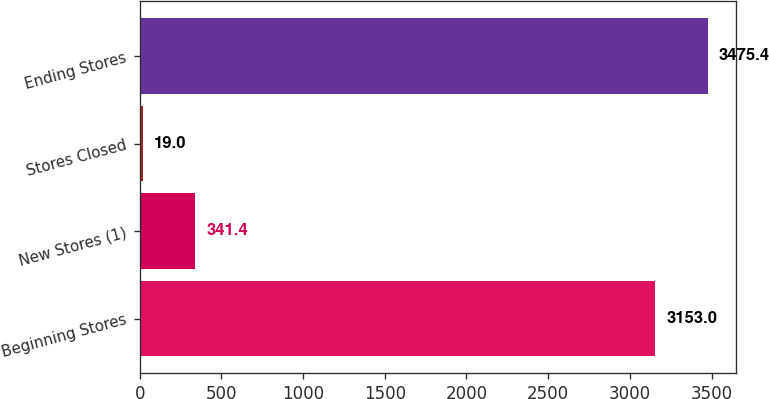<chart> <loc_0><loc_0><loc_500><loc_500><bar_chart><fcel>Beginning Stores<fcel>New Stores (1)<fcel>Stores Closed<fcel>Ending Stores<nl><fcel>3153<fcel>341.4<fcel>19<fcel>3475.4<nl></chart> 